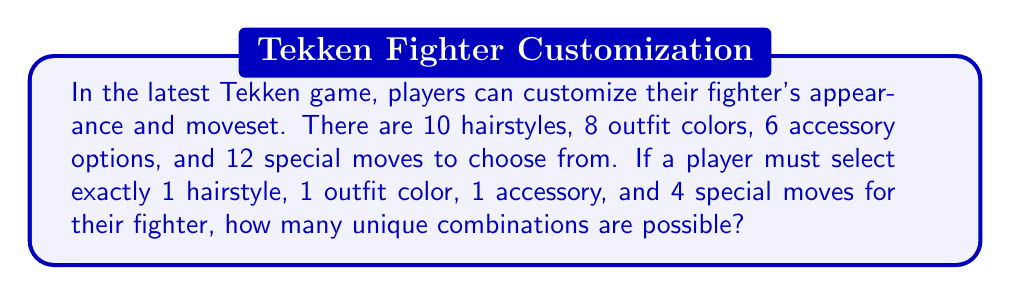Provide a solution to this math problem. Let's break this down step-by-step:

1. Hairstyle selection: There are 10 options, and we must choose 1.
   This is a straightforward choice with 10 possibilities.

2. Outfit color: There are 8 options, and we must choose 1.
   Again, this is a straightforward choice with 8 possibilities.

3. Accessory: There are 6 options, and we must choose 1.
   Once more, this is a straightforward choice with 6 possibilities.

4. Special moves: There are 12 options, and we must choose 4.
   This is a combination problem. We can calculate this using the combination formula:
   $$\binom{12}{4} = \frac{12!}{4!(12-4)!} = \frac{12!}{4!8!} = 495$$

5. To find the total number of unique combinations, we multiply all these possibilities together:

   $$ 10 \times 8 \times 6 \times 495 = 237,600 $$

This multiplication follows the multiplication principle of counting, where we multiply the number of ways each independent choice can be made.
Answer: 237,600 